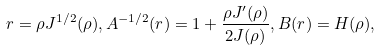<formula> <loc_0><loc_0><loc_500><loc_500>r = \rho J ^ { 1 / 2 } ( \rho ) , A ^ { - 1 / 2 } ( r ) = 1 + \frac { \rho J ^ { \prime } ( \rho ) } { 2 J ( \rho ) } , B ( r ) = H ( \rho ) ,</formula> 